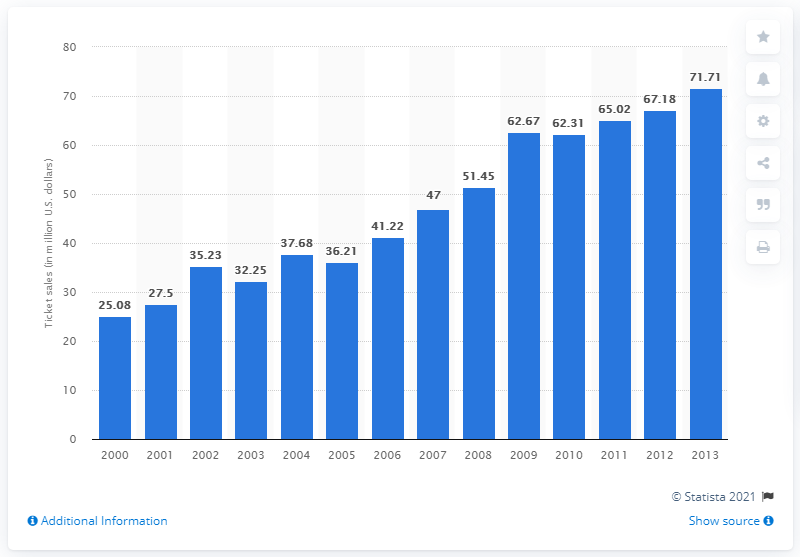Give some essential details in this illustration. In 2010, the total amount of money generated from ticket sales was $62,310. 